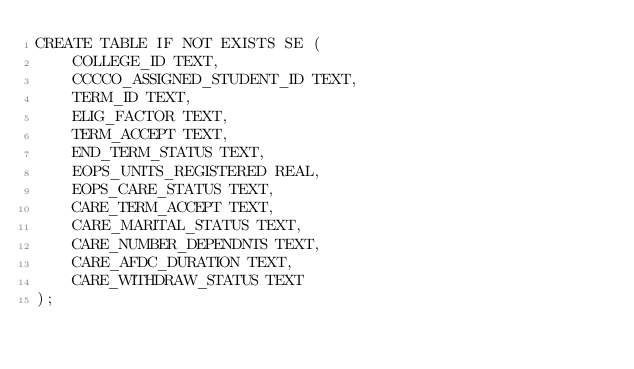<code> <loc_0><loc_0><loc_500><loc_500><_SQL_>CREATE TABLE IF NOT EXISTS SE (
    COLLEGE_ID TEXT,
    CCCCO_ASSIGNED_STUDENT_ID TEXT,
    TERM_ID TEXT,
    ELIG_FACTOR TEXT,
    TERM_ACCEPT TEXT,
    END_TERM_STATUS TEXT,
    EOPS_UNITS_REGISTERED REAL,
    EOPS_CARE_STATUS TEXT,
    CARE_TERM_ACCEPT TEXT,
    CARE_MARITAL_STATUS TEXT,
    CARE_NUMBER_DEPENDNTS TEXT,
    CARE_AFDC_DURATION TEXT,
    CARE_WITHDRAW_STATUS TEXT
);
</code> 